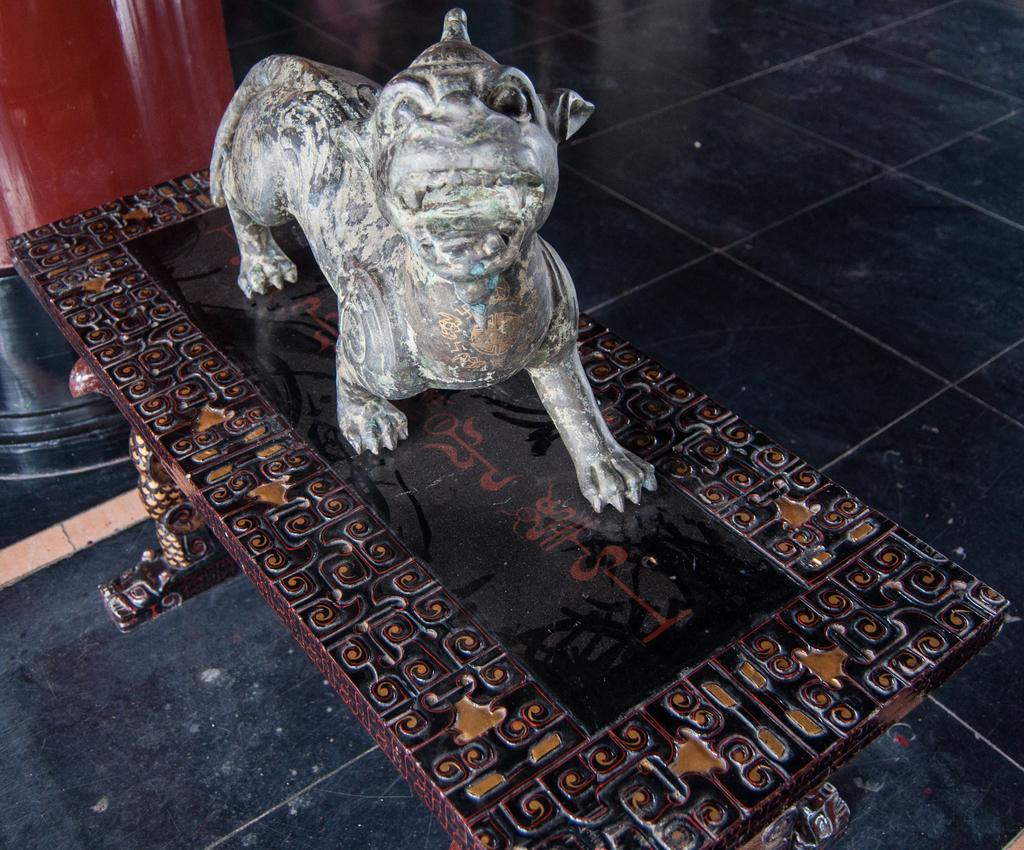What is the main piece of furniture in the image? There is a table in the image. What is placed on the table? There is a statue on the table. Can you describe the objects in the background of the image? In the background, there is an object that is red in color and another object that is black in color. What type of noise can be heard coming from the pail in the image? There is no pail present in the image, so it is not possible to determine what, if any, noise might be heard. 